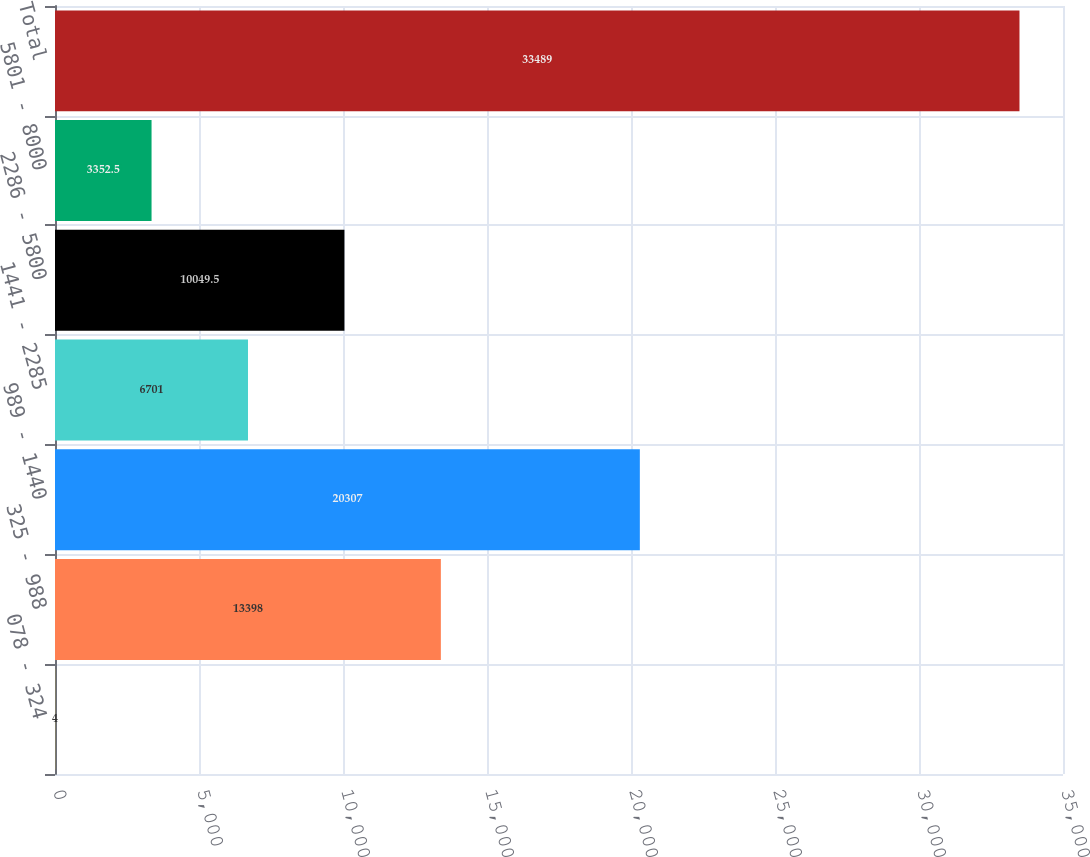Convert chart. <chart><loc_0><loc_0><loc_500><loc_500><bar_chart><fcel>078 - 324<fcel>325 - 988<fcel>989 - 1440<fcel>1441 - 2285<fcel>2286 - 5800<fcel>5801 - 8000<fcel>Total<nl><fcel>4<fcel>13398<fcel>20307<fcel>6701<fcel>10049.5<fcel>3352.5<fcel>33489<nl></chart> 